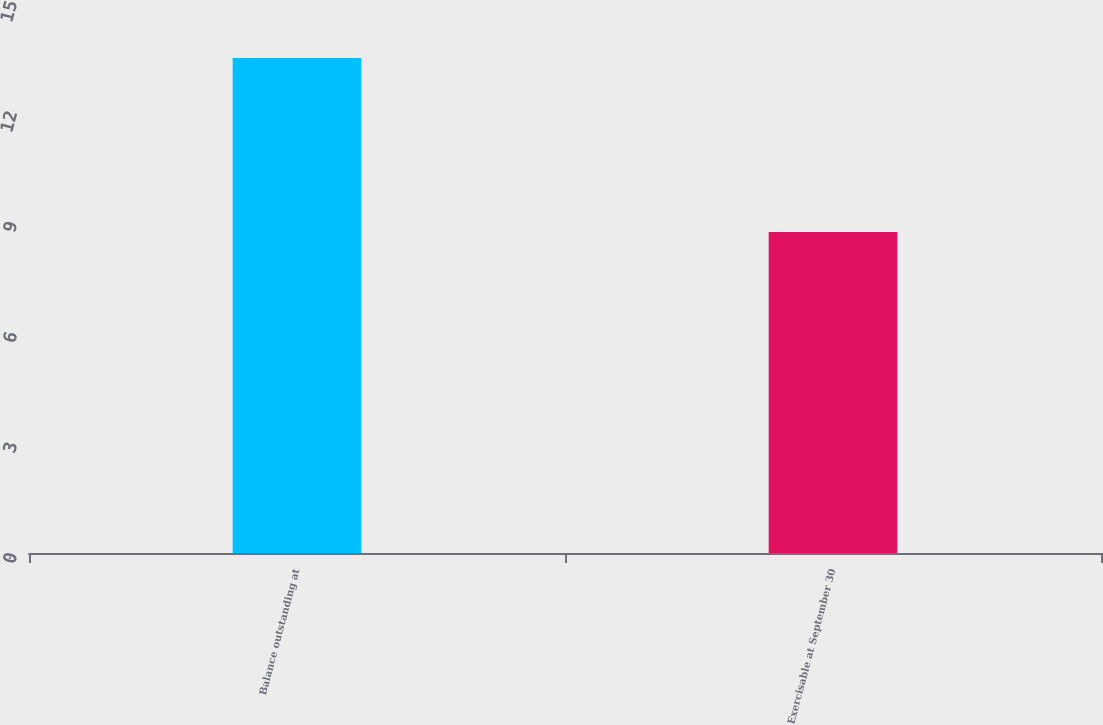Convert chart to OTSL. <chart><loc_0><loc_0><loc_500><loc_500><bar_chart><fcel>Balance outstanding at<fcel>Exercisable at September 30<nl><fcel>13.45<fcel>8.72<nl></chart> 